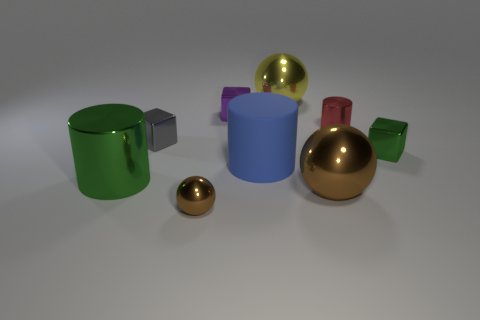The object that is the same color as the tiny ball is what size?
Keep it short and to the point. Large. Are there any brown metallic balls of the same size as the gray object?
Provide a succinct answer. Yes. How big is the metal cylinder behind the large shiny thing that is on the left side of the brown metallic ball that is left of the purple shiny cube?
Provide a succinct answer. Small. The small shiny cylinder has what color?
Keep it short and to the point. Red. Are there more big blue objects right of the tiny green metal block than small green metallic objects?
Offer a terse response. No. There is a blue rubber object; how many metal spheres are on the right side of it?
Give a very brief answer. 2. The thing that is the same color as the large metallic cylinder is what shape?
Your answer should be compact. Cube. There is a brown ball in front of the large metal sphere in front of the small red metal object; are there any small red cylinders in front of it?
Offer a terse response. No. Do the purple block and the gray object have the same size?
Offer a terse response. Yes. Are there an equal number of small red metal things that are left of the big blue cylinder and large yellow shiny objects in front of the large yellow shiny object?
Offer a terse response. Yes. 